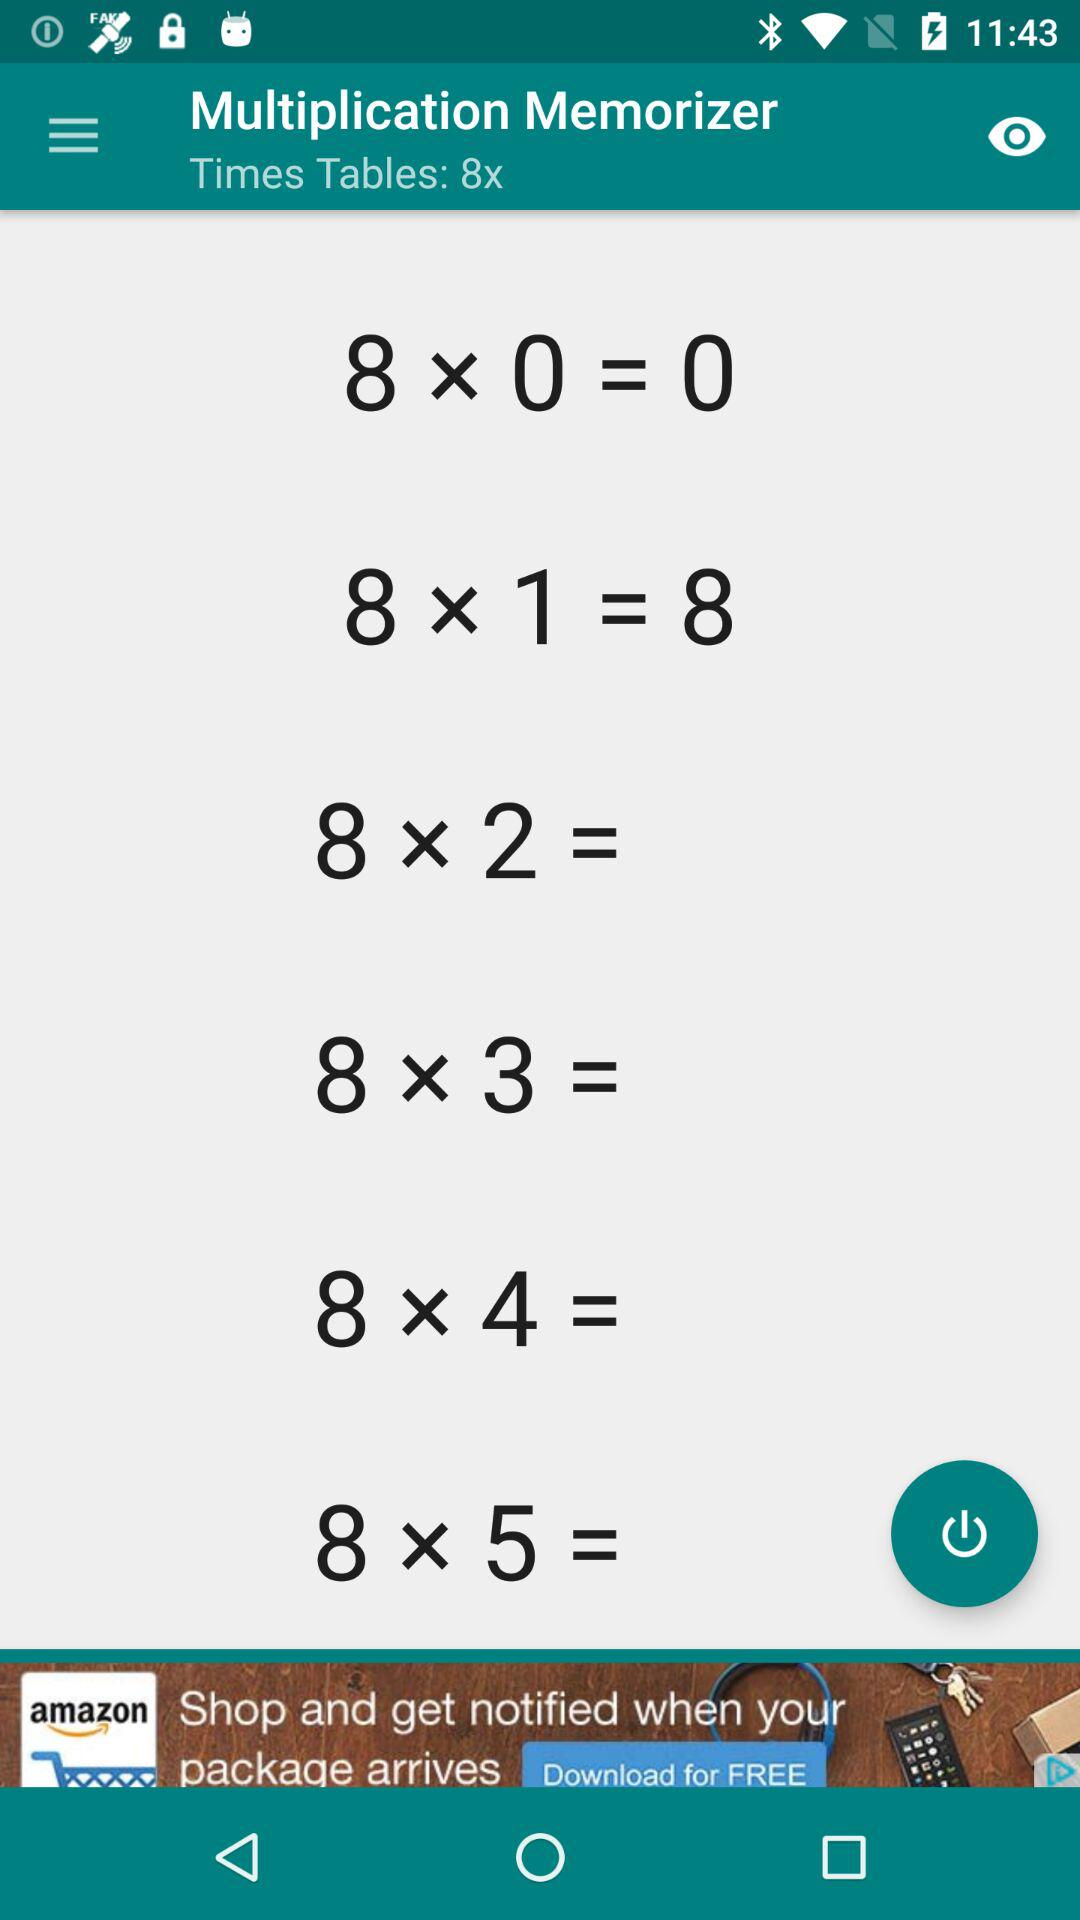How many times tables are shown on the screen?
Answer the question using a single word or phrase. 6 